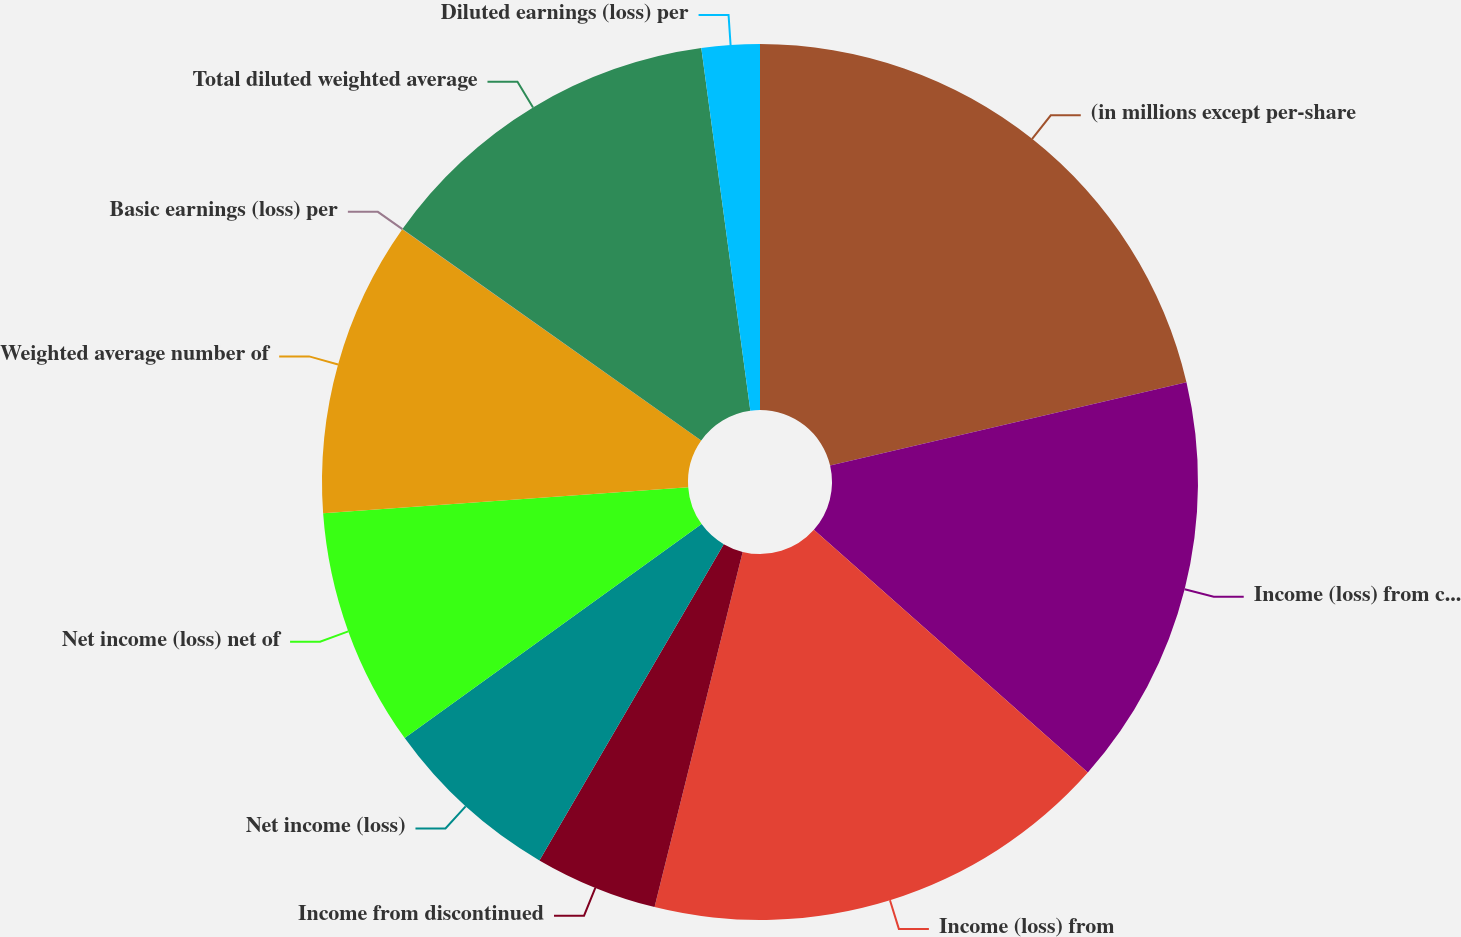<chart> <loc_0><loc_0><loc_500><loc_500><pie_chart><fcel>(in millions except per-share<fcel>Income (loss) from continuing<fcel>Income (loss) from<fcel>Income from discontinued<fcel>Net income (loss)<fcel>Net income (loss) net of<fcel>Weighted average number of<fcel>Basic earnings (loss) per<fcel>Total diluted weighted average<fcel>Diluted earnings (loss) per<nl><fcel>21.34%<fcel>15.2%<fcel>17.33%<fcel>4.53%<fcel>6.66%<fcel>8.8%<fcel>10.93%<fcel>0.01%<fcel>13.06%<fcel>2.14%<nl></chart> 